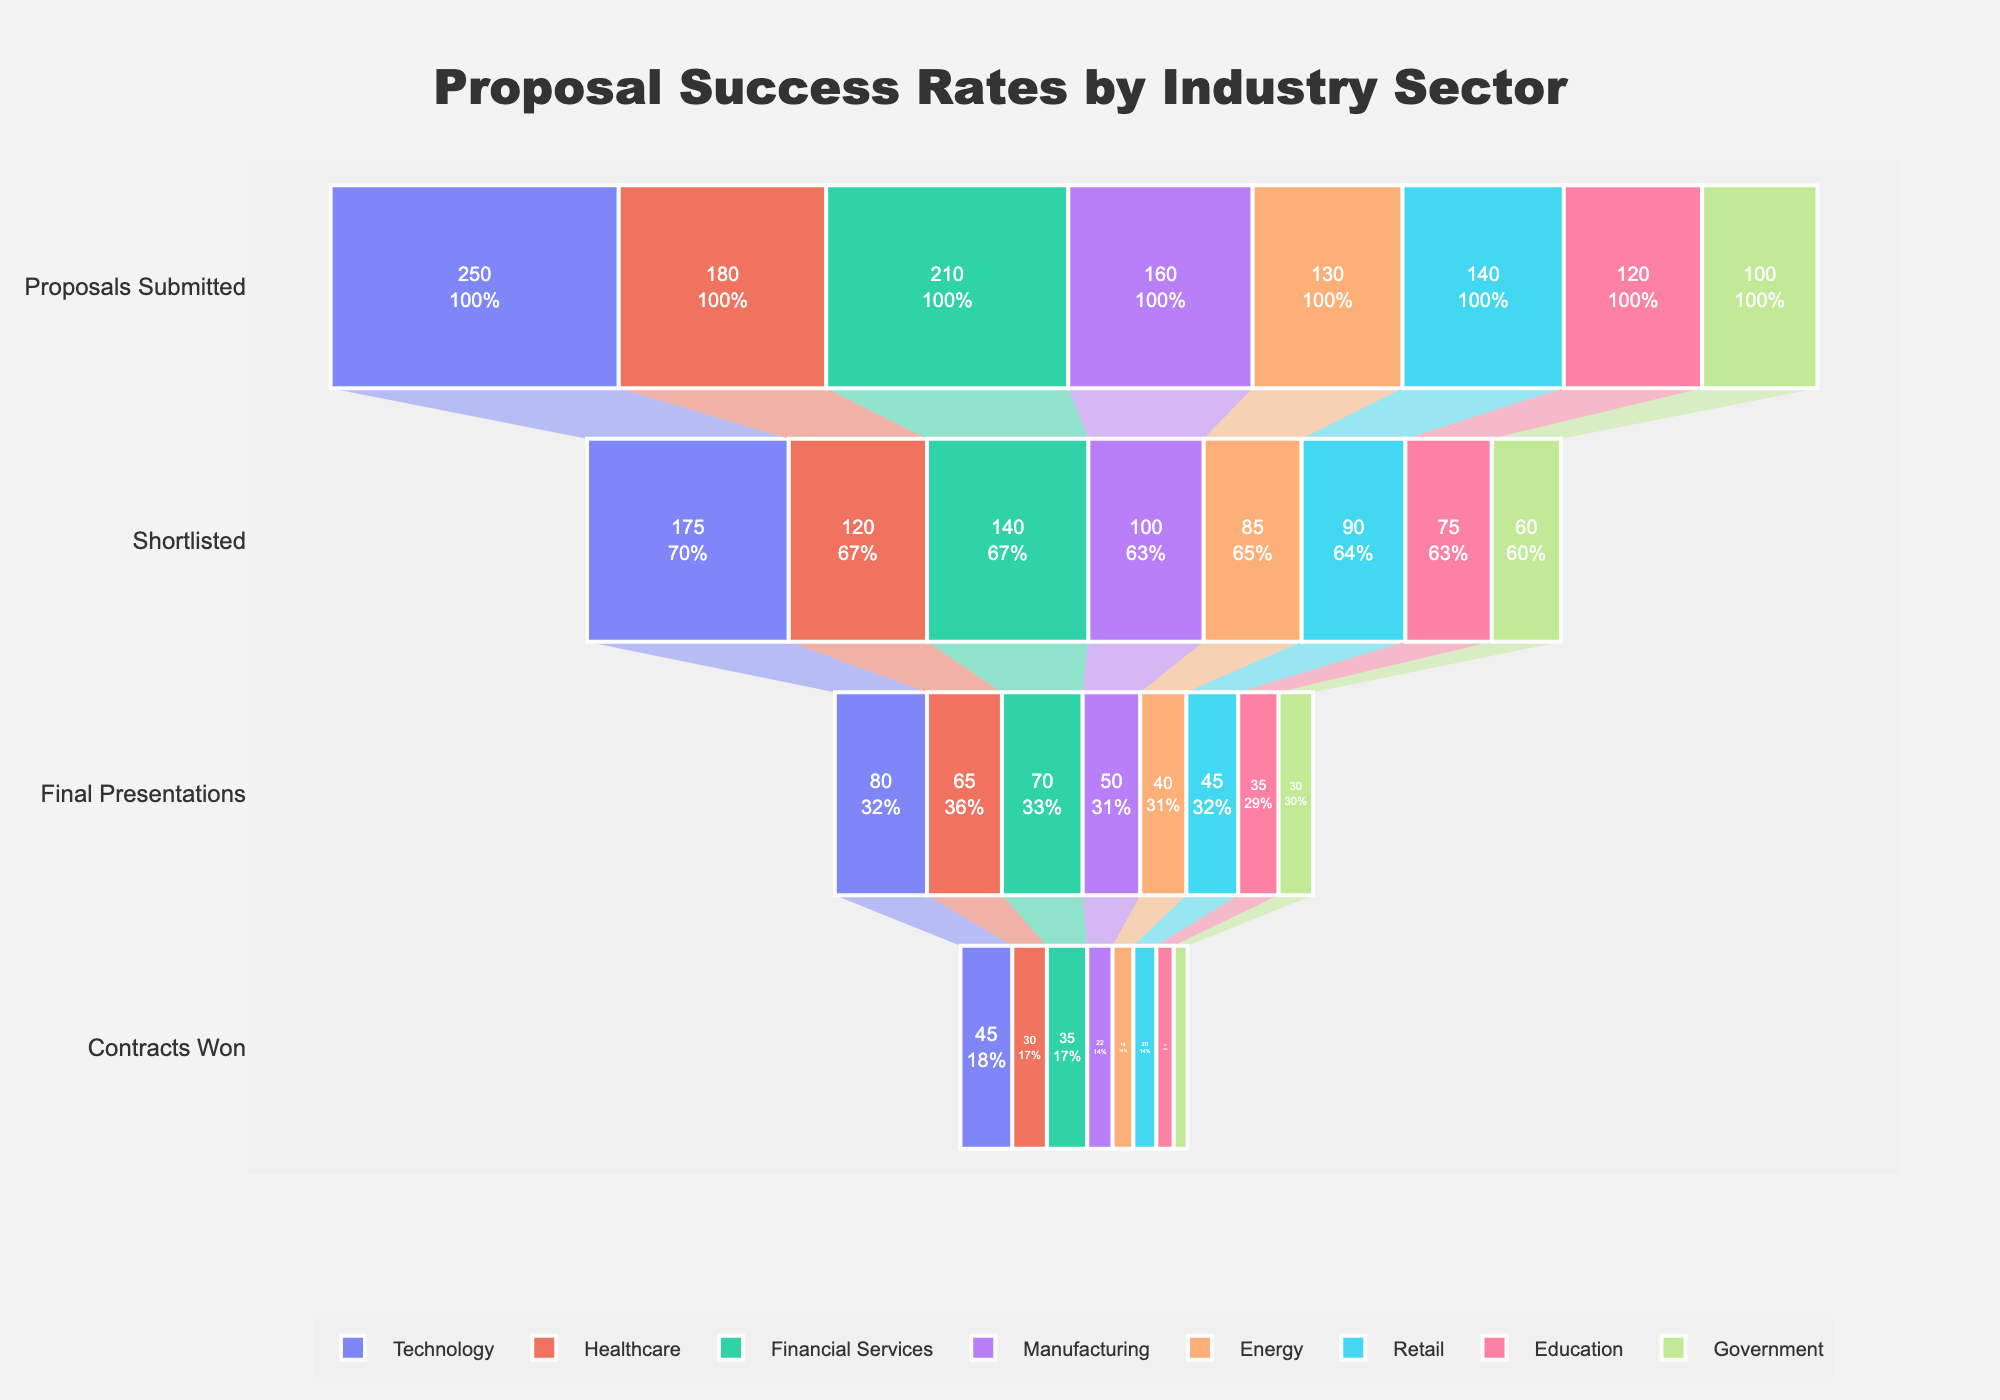What's the title of the chart? The title is typically positioned at the top of the chart. In this case, it is centered right below the top margin.
Answer: Proposal Success Rates by Industry Sector How many industry sectors are represented in the chart? The chart shows different colored segments representing various industry sectors in the funnel chart. By counting them, we find there are eight industry sectors.
Answer: 8 Which industry sector has the highest number of proposals submitted? The figure shows the 'Proposals Submitted' stage at the top of each funnel. The length of the segment for the Technology sector is the longest here, representing the highest number.
Answer: Technology Which industry sector has the lowest number of contracts won? The bottom part of the funnels represents the 'Contracts Won'. The shortest segment here corresponds to the Government sector.
Answer: Government How many contracts were won in the Retail sector? From the 'Contracts Won' stage for the Retail sector, the number displayed inside this part of the funnel is visible. It reads 20.
Answer: 20 What's the difference in the number of contracts won between the Technology and Healthcare sectors? From the bottom of their respective funnels, Technology has 45 contracts won and Healthcare has 30. Subtracting these values gives 45 - 30 = 15.
Answer: 15 What percentage of proposals submitted in the Financial Services sector were shortlisted? From the stages of the funnel for Financial Services, the initial number is 210 for 'Proposals Submitted' and 140 for 'Shortlisted'. The percentage is calculated as (140 / 210) * 100 ≈ 66.67%.
Answer: 66.67% Which sector has the highest conversion rate from final presentations to contracts won? Comparing the 'Final Presentations' to the 'Contracts Won' stages across sectors, the conversion rate can be calculated. Technology: (45/80), Healthcare: (30/65), Financial Services: (35/70), Manufacturing: (22/50), Energy: (18/40), Retail: (20/45), Education: (15/35), Government: (12/30). Dividing each, the highest rate is about 56.25% for the Technology sector.
Answer: Technology How many more proposals were submitted in the Technology sector compared to the Manufacturing sector? The 'Proposals Submitted' stage for Technology has 250 proposals while Manufacturing has 160 proposals. Subtracting these values gives 250 - 160 = 90.
Answer: 90 